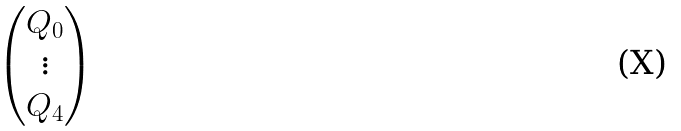Convert formula to latex. <formula><loc_0><loc_0><loc_500><loc_500>\begin{pmatrix} Q _ { 0 } \\ \vdots \\ Q _ { 4 } \end{pmatrix}</formula> 